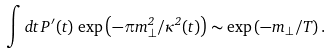Convert formula to latex. <formula><loc_0><loc_0><loc_500><loc_500>\int d t \, P ^ { \, \prime } ( t ) \, \exp \left ( - \pi m ^ { 2 } _ { \perp } / \kappa ^ { 2 } ( t ) \right ) \sim \exp \left ( - m _ { \perp } / T \right ) .</formula> 